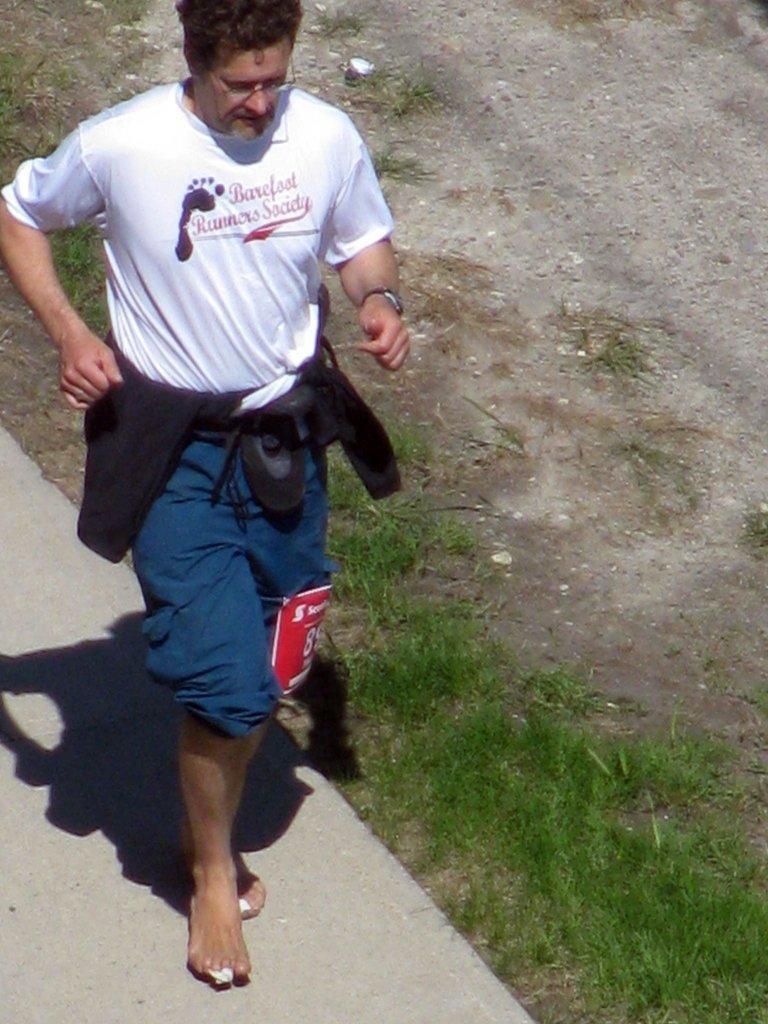How would you summarize this image in a sentence or two? In this image we can see a man wearing the glasses. We can also see some text paper tied to his knee. In the background we can see the grass, ground and also the path. 